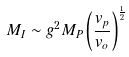<formula> <loc_0><loc_0><loc_500><loc_500>M _ { I } \sim g ^ { 2 } M _ { P } \left ( { \frac { v _ { p } } { v _ { o } } } \right ) ^ { \frac { 1 } { 2 } }</formula> 